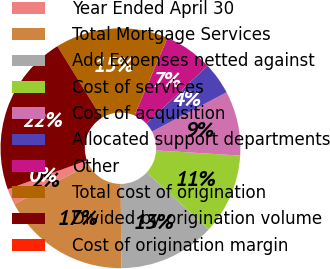<chart> <loc_0><loc_0><loc_500><loc_500><pie_chart><fcel>Year Ended April 30<fcel>Total Mortgage Services<fcel>Add Expenses netted against<fcel>Cost of services<fcel>Cost of acquisition<fcel>Allocated support departments<fcel>Other<fcel>Total cost of origination<fcel>Divided by origination volume<fcel>Cost of origination margin<nl><fcel>2.17%<fcel>17.39%<fcel>13.04%<fcel>10.87%<fcel>8.7%<fcel>4.35%<fcel>6.52%<fcel>15.22%<fcel>21.74%<fcel>0.0%<nl></chart> 